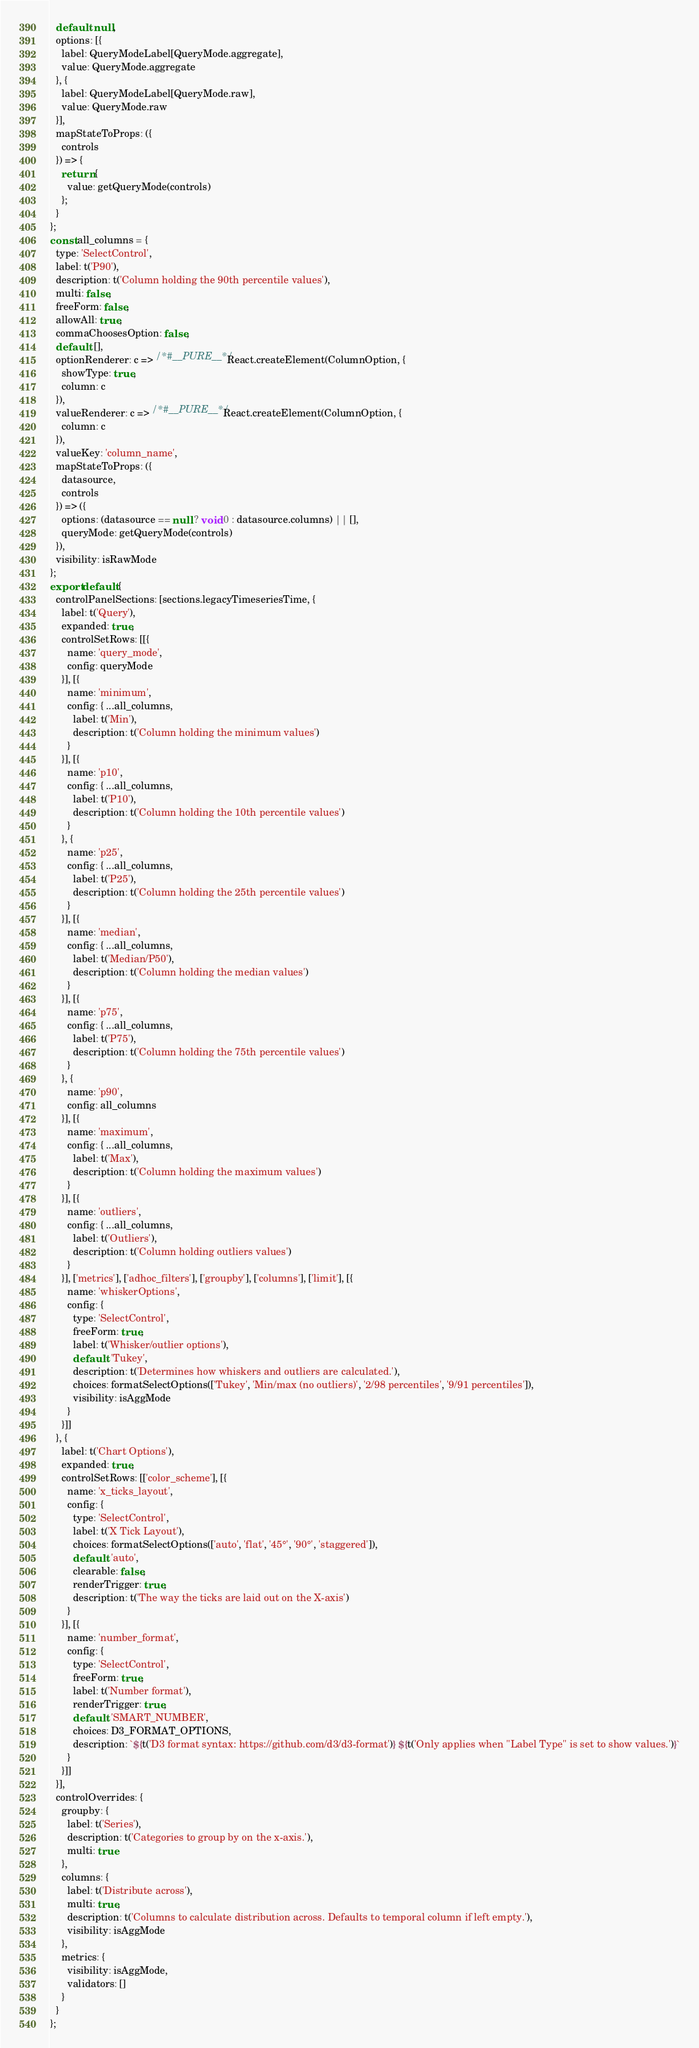<code> <loc_0><loc_0><loc_500><loc_500><_JavaScript_>  default: null,
  options: [{
    label: QueryModeLabel[QueryMode.aggregate],
    value: QueryMode.aggregate
  }, {
    label: QueryModeLabel[QueryMode.raw],
    value: QueryMode.raw
  }],
  mapStateToProps: ({
    controls
  }) => {
    return {
      value: getQueryMode(controls)
    };
  }
};
const all_columns = {
  type: 'SelectControl',
  label: t('P90'),
  description: t('Column holding the 90th percentile values'),
  multi: false,
  freeForm: false,
  allowAll: true,
  commaChoosesOption: false,
  default: [],
  optionRenderer: c => /*#__PURE__*/React.createElement(ColumnOption, {
    showType: true,
    column: c
  }),
  valueRenderer: c => /*#__PURE__*/React.createElement(ColumnOption, {
    column: c
  }),
  valueKey: 'column_name',
  mapStateToProps: ({
    datasource,
    controls
  }) => ({
    options: (datasource == null ? void 0 : datasource.columns) || [],
    queryMode: getQueryMode(controls)
  }),
  visibility: isRawMode
};
export default {
  controlPanelSections: [sections.legacyTimeseriesTime, {
    label: t('Query'),
    expanded: true,
    controlSetRows: [[{
      name: 'query_mode',
      config: queryMode
    }], [{
      name: 'minimum',
      config: { ...all_columns,
        label: t('Min'),
        description: t('Column holding the minimum values')
      }
    }], [{
      name: 'p10',
      config: { ...all_columns,
        label: t('P10'),
        description: t('Column holding the 10th percentile values')
      }
    }, {
      name: 'p25',
      config: { ...all_columns,
        label: t('P25'),
        description: t('Column holding the 25th percentile values')
      }
    }], [{
      name: 'median',
      config: { ...all_columns,
        label: t('Median/P50'),
        description: t('Column holding the median values')
      }
    }], [{
      name: 'p75',
      config: { ...all_columns,
        label: t('P75'),
        description: t('Column holding the 75th percentile values')
      }
    }, {
      name: 'p90',
      config: all_columns
    }], [{
      name: 'maximum',
      config: { ...all_columns,
        label: t('Max'),
        description: t('Column holding the maximum values')
      }
    }], [{
      name: 'outliers',
      config: { ...all_columns,
        label: t('Outliers'),
        description: t('Column holding outliers values')
      }
    }], ['metrics'], ['adhoc_filters'], ['groupby'], ['columns'], ['limit'], [{
      name: 'whiskerOptions',
      config: {
        type: 'SelectControl',
        freeForm: true,
        label: t('Whisker/outlier options'),
        default: 'Tukey',
        description: t('Determines how whiskers and outliers are calculated.'),
        choices: formatSelectOptions(['Tukey', 'Min/max (no outliers)', '2/98 percentiles', '9/91 percentiles']),
        visibility: isAggMode
      }
    }]]
  }, {
    label: t('Chart Options'),
    expanded: true,
    controlSetRows: [['color_scheme'], [{
      name: 'x_ticks_layout',
      config: {
        type: 'SelectControl',
        label: t('X Tick Layout'),
        choices: formatSelectOptions(['auto', 'flat', '45°', '90°', 'staggered']),
        default: 'auto',
        clearable: false,
        renderTrigger: true,
        description: t('The way the ticks are laid out on the X-axis')
      }
    }], [{
      name: 'number_format',
      config: {
        type: 'SelectControl',
        freeForm: true,
        label: t('Number format'),
        renderTrigger: true,
        default: 'SMART_NUMBER',
        choices: D3_FORMAT_OPTIONS,
        description: `${t('D3 format syntax: https://github.com/d3/d3-format')} ${t('Only applies when "Label Type" is set to show values.')}`
      }
    }]]
  }],
  controlOverrides: {
    groupby: {
      label: t('Series'),
      description: t('Categories to group by on the x-axis.'),
      multi: true
    },
    columns: {
      label: t('Distribute across'),
      multi: true,
      description: t('Columns to calculate distribution across. Defaults to temporal column if left empty.'),
      visibility: isAggMode
    },
    metrics: {
      visibility: isAggMode,
      validators: []
    }
  }
};</code> 